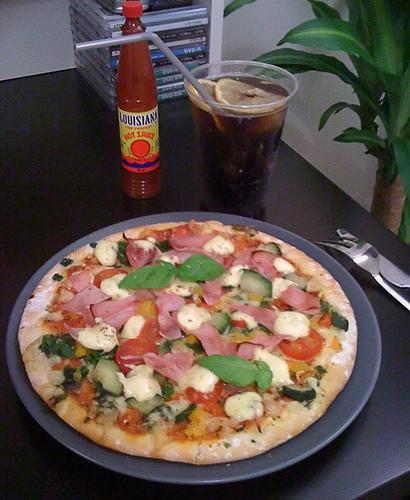Is this food Mexican in flavor?
Be succinct. No. What kind of pizza's are these?
Short answer required. Veggie. How many kinds of food?
Answer briefly. 1. How many CDs are there?
Concise answer only. 10. What are the yellow vegetables on the pizza?
Be succinct. Peppers. What kind of spice is being added to the dish?
Give a very brief answer. Hot sauce. What ingredients are on the pizza?
Give a very brief answer. Meats and veggies. What is the object next to the pizza?
Short answer required. Tea. Is this pizza cut?
Short answer required. No. What is in the bottle?
Quick response, please. Hot sauce. Are these pieces of pizza made for vegetarians?
Short answer required. No. What are the white globs on the pizza?
Keep it brief. Cheese. Can you identify at least one ingredient that has been grown?
Keep it brief. Basil. What kind of spicy meat is on the pizza?
Be succinct. Ham. Is that meat?
Short answer required. Yes. What color is the beverage?
Keep it brief. Brown. What eating utensils are next to the pizza?
Answer briefly. Fork and knife. Is the crust even?
Answer briefly. Yes. What color is the plate?
Write a very short answer. Black. How much silverware can be seen?
Give a very brief answer. 2. What shape is the plate?
Keep it brief. Round. Have the pizzas been baked?
Give a very brief answer. Yes. 